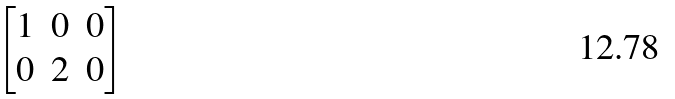<formula> <loc_0><loc_0><loc_500><loc_500>\begin{bmatrix} 1 & 0 & 0 \\ 0 & 2 & 0 \end{bmatrix}</formula> 